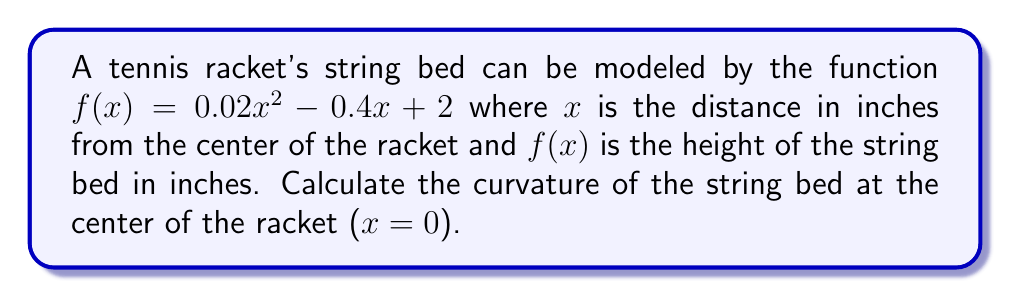Solve this math problem. To find the curvature at a point, we use the formula:

$$\kappa = \frac{|f''(x)|}{(1 + [f'(x)]^2)^{3/2}}$$

Step 1: Calculate $f'(x)$ and $f''(x)$
$f'(x) = 0.04x - 0.4$
$f''(x) = 0.04$

Step 2: Evaluate $f'(x)$ at $x = 0$
$f'(0) = 0.04(0) - 0.4 = -0.4$

Step 3: Evaluate $f''(x)$ at $x = 0$
$f''(0) = 0.04$

Step 4: Plug values into the curvature formula
$$\kappa = \frac{|0.04|}{(1 + [-0.4]^2)^{3/2}}$$

Step 5: Simplify
$$\kappa = \frac{0.04}{(1 + 0.16)^{3/2}} = \frac{0.04}{1.16^{3/2}}$$

Step 6: Calculate the final result
$$\kappa \approx 0.0336$$

This value represents the curvature of the string bed at the center of the racket, which is relevant for understanding how the ball will react upon impact at different points on the racket face.
Answer: $0.0336$ in$^{-1}$ 